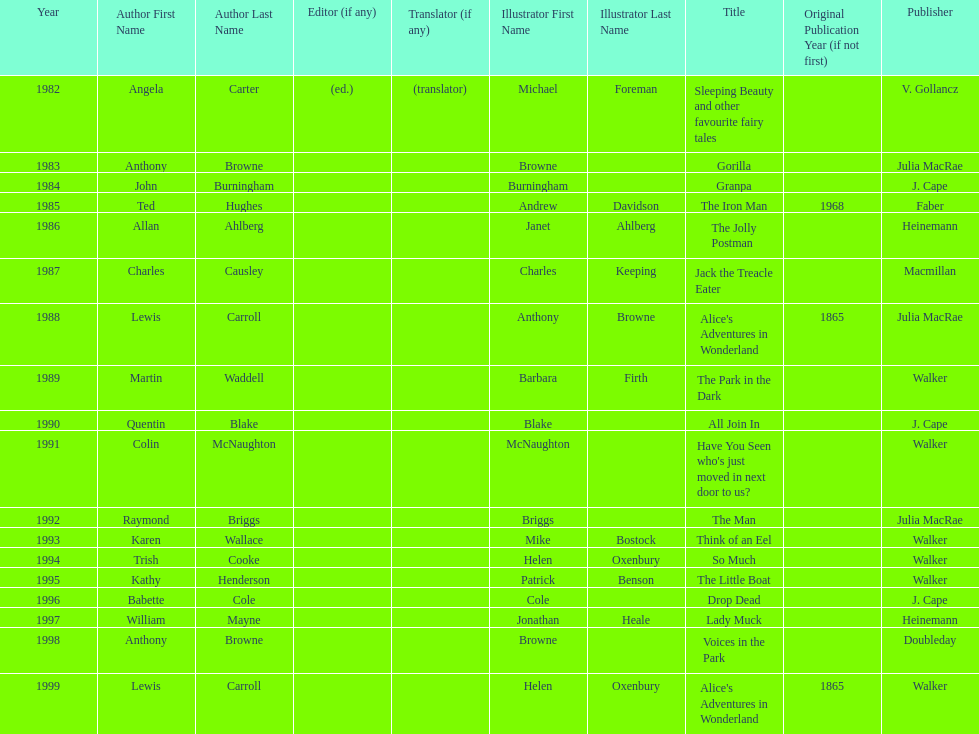Which book won the award a total of 2 times? Alice's Adventures in Wonderland. Can you parse all the data within this table? {'header': ['Year', 'Author First Name', 'Author Last Name', 'Editor (if any)', 'Translator (if any)', 'Illustrator First Name', 'Illustrator Last Name', 'Title', 'Original Publication Year (if not first)', 'Publisher'], 'rows': [['1982', 'Angela', 'Carter', '(ed.)', '(translator)', 'Michael', 'Foreman', 'Sleeping Beauty and other favourite fairy tales', '', 'V. Gollancz'], ['1983', 'Anthony', 'Browne', '', '', 'Browne', '', 'Gorilla', '', 'Julia MacRae'], ['1984', 'John', 'Burningham', '', '', 'Burningham', '', 'Granpa', '', 'J. Cape'], ['1985', 'Ted', 'Hughes', '', '', 'Andrew', 'Davidson', 'The Iron Man', '1968', 'Faber'], ['1986', 'Allan', 'Ahlberg', '', '', 'Janet', 'Ahlberg', 'The Jolly Postman', '', 'Heinemann'], ['1987', 'Charles', 'Causley', '', '', 'Charles', 'Keeping', 'Jack the Treacle Eater', '', 'Macmillan'], ['1988', 'Lewis', 'Carroll', '', '', 'Anthony', 'Browne', "Alice's Adventures in Wonderland", '1865', 'Julia MacRae'], ['1989', 'Martin', 'Waddell', '', '', 'Barbara', 'Firth', 'The Park in the Dark', '', 'Walker'], ['1990', 'Quentin', 'Blake', '', '', 'Blake', '', 'All Join In', '', 'J. Cape'], ['1991', 'Colin', 'McNaughton', '', '', 'McNaughton', '', "Have You Seen who's just moved in next door to us?", '', 'Walker'], ['1992', 'Raymond', 'Briggs', '', '', 'Briggs', '', 'The Man', '', 'Julia MacRae'], ['1993', 'Karen', 'Wallace', '', '', 'Mike', 'Bostock', 'Think of an Eel', '', 'Walker'], ['1994', 'Trish', 'Cooke', '', '', 'Helen', 'Oxenbury', 'So Much', '', 'Walker'], ['1995', 'Kathy', 'Henderson', '', '', 'Patrick', 'Benson', 'The Little Boat', '', 'Walker'], ['1996', 'Babette', 'Cole', '', '', 'Cole', '', 'Drop Dead', '', 'J. Cape'], ['1997', 'William', 'Mayne', '', '', 'Jonathan', 'Heale', 'Lady Muck', '', 'Heinemann'], ['1998', 'Anthony', 'Browne', '', '', 'Browne', '', 'Voices in the Park', '', 'Doubleday'], ['1999', 'Lewis', 'Carroll', '', '', 'Helen', 'Oxenbury', "Alice's Adventures in Wonderland", '1865', 'Walker']]} 